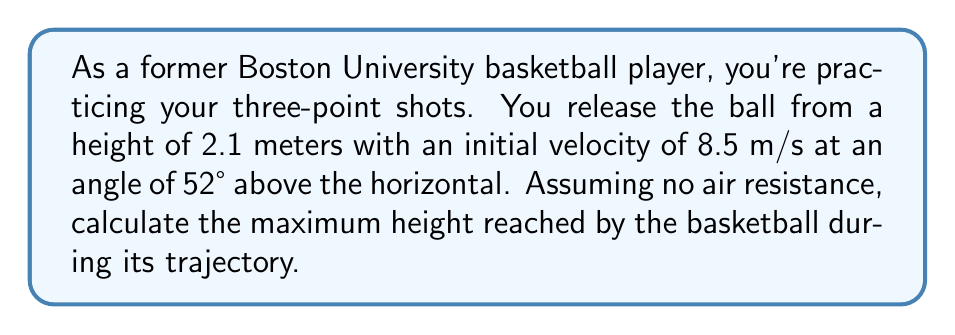Provide a solution to this math problem. Let's approach this step-by-step using projectile motion equations:

1) First, we need to find the vertical component of the initial velocity:
   $v_{0y} = v_0 \sin \theta = 8.5 \sin 52° = 6.71$ m/s

2) The maximum height is reached when the vertical velocity becomes zero. We can use the equation:
   $v_y^2 = v_{0y}^2 - 2g(y - y_0)$

   Where:
   $v_y = 0$ (at maximum height)
   $v_{0y} = 6.71$ m/s
   $g = 9.8$ m/s² (acceleration due to gravity)
   $y_0 = 2.1$ m (initial height)
   $y = h_{max}$ (maximum height, what we're solving for)

3) Substituting these values:
   $0^2 = 6.71^2 - 2(9.8)(h_{max} - 2.1)$

4) Simplifying:
   $45.0241 = 19.6(h_{max} - 2.1)$
   $45.0241 = 19.6h_{max} - 41.16$
   $86.1841 = 19.6h_{max}$

5) Solving for $h_{max}$:
   $h_{max} = \frac{86.1841}{19.6} = 4.397$ m

6) The maximum height reached is 4.397 m. However, this is from the ground level. To find the maximum height above the release point, we subtract the initial height:
   $h_{above\_release} = 4.397 - 2.1 = 2.297$ m

Therefore, the basketball reaches a maximum height of 2.297 meters above the release point.
Answer: 2.30 m 